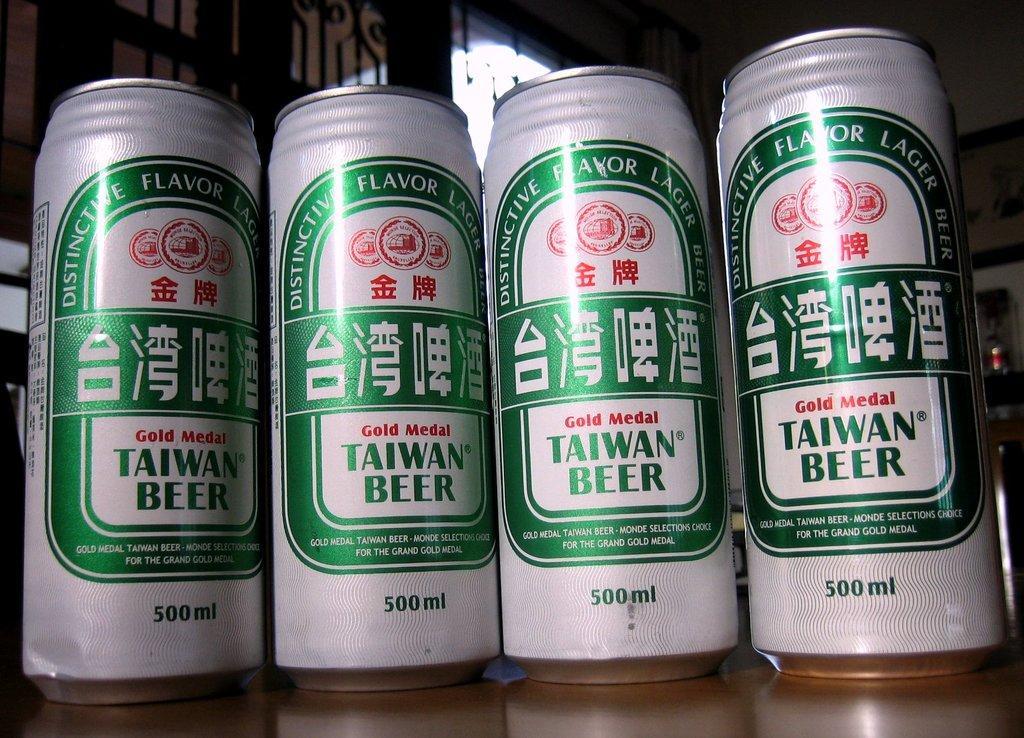Can you describe this image briefly? In this picture there are beer tins in the center of the image and there are windows in the background area of the image. 